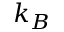Convert formula to latex. <formula><loc_0><loc_0><loc_500><loc_500>k _ { B }</formula> 